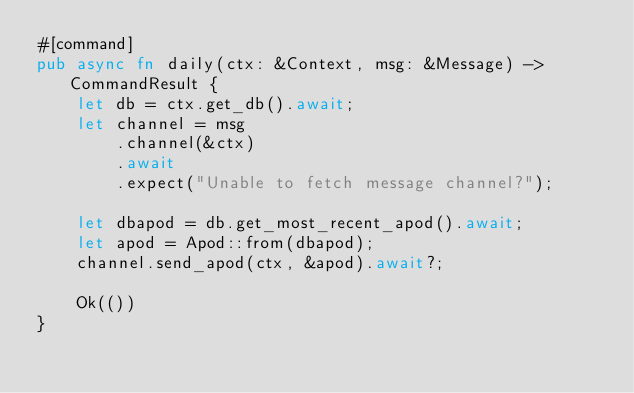Convert code to text. <code><loc_0><loc_0><loc_500><loc_500><_Rust_>#[command]
pub async fn daily(ctx: &Context, msg: &Message) -> CommandResult {
    let db = ctx.get_db().await;
    let channel = msg
        .channel(&ctx)
        .await
        .expect("Unable to fetch message channel?");

    let dbapod = db.get_most_recent_apod().await;
    let apod = Apod::from(dbapod);
    channel.send_apod(ctx, &apod).await?;

    Ok(())
}
</code> 